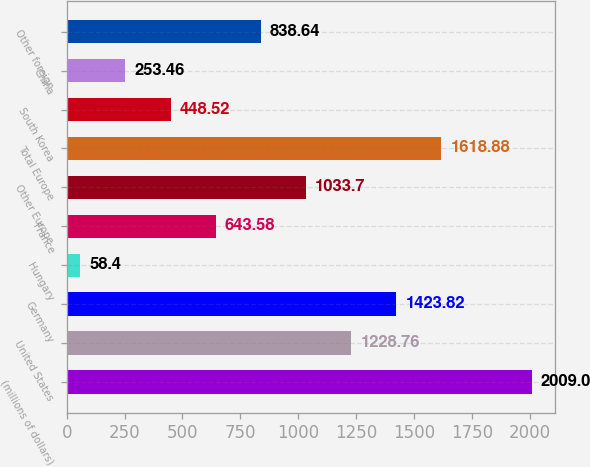Convert chart to OTSL. <chart><loc_0><loc_0><loc_500><loc_500><bar_chart><fcel>(millions of dollars)<fcel>United States<fcel>Germany<fcel>Hungary<fcel>France<fcel>Other Europe<fcel>Total Europe<fcel>South Korea<fcel>China<fcel>Other foreign<nl><fcel>2009<fcel>1228.76<fcel>1423.82<fcel>58.4<fcel>643.58<fcel>1033.7<fcel>1618.88<fcel>448.52<fcel>253.46<fcel>838.64<nl></chart> 